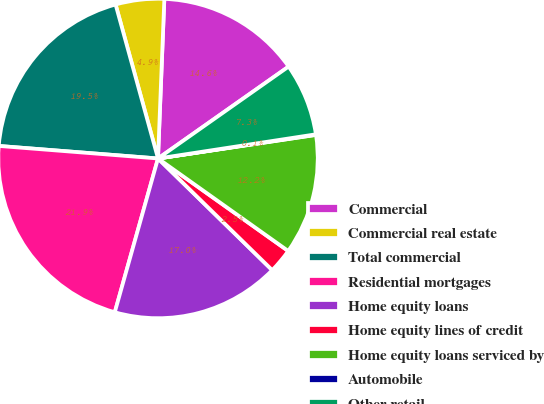Convert chart to OTSL. <chart><loc_0><loc_0><loc_500><loc_500><pie_chart><fcel>Commercial<fcel>Commercial real estate<fcel>Total commercial<fcel>Residential mortgages<fcel>Home equity loans<fcel>Home equity lines of credit<fcel>Home equity loans serviced by<fcel>Automobile<fcel>Other retail<nl><fcel>14.61%<fcel>4.91%<fcel>19.47%<fcel>21.89%<fcel>17.04%<fcel>2.49%<fcel>12.19%<fcel>0.06%<fcel>7.34%<nl></chart> 